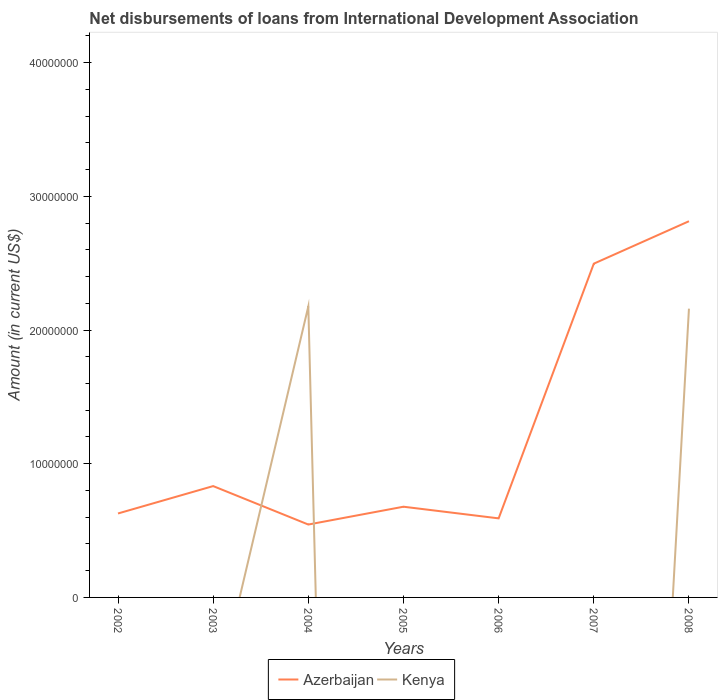How many different coloured lines are there?
Your answer should be very brief. 2. Does the line corresponding to Kenya intersect with the line corresponding to Azerbaijan?
Make the answer very short. Yes. What is the total amount of loans disbursed in Azerbaijan in the graph?
Give a very brief answer. 1.54e+06. What is the difference between the highest and the second highest amount of loans disbursed in Azerbaijan?
Ensure brevity in your answer.  2.27e+07. What is the difference between the highest and the lowest amount of loans disbursed in Azerbaijan?
Offer a terse response. 2. What is the difference between two consecutive major ticks on the Y-axis?
Offer a very short reply. 1.00e+07. Does the graph contain any zero values?
Keep it short and to the point. Yes. Does the graph contain grids?
Provide a short and direct response. No. How many legend labels are there?
Offer a terse response. 2. How are the legend labels stacked?
Ensure brevity in your answer.  Horizontal. What is the title of the graph?
Your response must be concise. Net disbursements of loans from International Development Association. Does "Puerto Rico" appear as one of the legend labels in the graph?
Provide a short and direct response. No. What is the label or title of the X-axis?
Provide a succinct answer. Years. What is the Amount (in current US$) in Azerbaijan in 2002?
Make the answer very short. 6.28e+06. What is the Amount (in current US$) in Azerbaijan in 2003?
Make the answer very short. 8.33e+06. What is the Amount (in current US$) of Azerbaijan in 2004?
Give a very brief answer. 5.45e+06. What is the Amount (in current US$) of Kenya in 2004?
Your answer should be very brief. 2.18e+07. What is the Amount (in current US$) of Azerbaijan in 2005?
Offer a very short reply. 6.78e+06. What is the Amount (in current US$) in Azerbaijan in 2006?
Your response must be concise. 5.91e+06. What is the Amount (in current US$) of Kenya in 2006?
Your answer should be compact. 0. What is the Amount (in current US$) in Azerbaijan in 2007?
Offer a terse response. 2.50e+07. What is the Amount (in current US$) of Kenya in 2007?
Offer a very short reply. 0. What is the Amount (in current US$) in Azerbaijan in 2008?
Make the answer very short. 2.81e+07. What is the Amount (in current US$) in Kenya in 2008?
Make the answer very short. 2.16e+07. Across all years, what is the maximum Amount (in current US$) in Azerbaijan?
Offer a terse response. 2.81e+07. Across all years, what is the maximum Amount (in current US$) of Kenya?
Make the answer very short. 2.18e+07. Across all years, what is the minimum Amount (in current US$) of Azerbaijan?
Provide a succinct answer. 5.45e+06. Across all years, what is the minimum Amount (in current US$) in Kenya?
Give a very brief answer. 0. What is the total Amount (in current US$) in Azerbaijan in the graph?
Offer a very short reply. 8.59e+07. What is the total Amount (in current US$) in Kenya in the graph?
Ensure brevity in your answer.  4.34e+07. What is the difference between the Amount (in current US$) in Azerbaijan in 2002 and that in 2003?
Give a very brief answer. -2.05e+06. What is the difference between the Amount (in current US$) of Azerbaijan in 2002 and that in 2004?
Your answer should be very brief. 8.27e+05. What is the difference between the Amount (in current US$) in Azerbaijan in 2002 and that in 2005?
Ensure brevity in your answer.  -5.05e+05. What is the difference between the Amount (in current US$) of Azerbaijan in 2002 and that in 2006?
Provide a succinct answer. 3.66e+05. What is the difference between the Amount (in current US$) of Azerbaijan in 2002 and that in 2007?
Your answer should be compact. -1.87e+07. What is the difference between the Amount (in current US$) of Azerbaijan in 2002 and that in 2008?
Offer a terse response. -2.19e+07. What is the difference between the Amount (in current US$) in Azerbaijan in 2003 and that in 2004?
Ensure brevity in your answer.  2.88e+06. What is the difference between the Amount (in current US$) of Azerbaijan in 2003 and that in 2005?
Offer a very short reply. 1.54e+06. What is the difference between the Amount (in current US$) in Azerbaijan in 2003 and that in 2006?
Give a very brief answer. 2.41e+06. What is the difference between the Amount (in current US$) in Azerbaijan in 2003 and that in 2007?
Your answer should be very brief. -1.66e+07. What is the difference between the Amount (in current US$) of Azerbaijan in 2003 and that in 2008?
Give a very brief answer. -1.98e+07. What is the difference between the Amount (in current US$) in Azerbaijan in 2004 and that in 2005?
Make the answer very short. -1.33e+06. What is the difference between the Amount (in current US$) in Azerbaijan in 2004 and that in 2006?
Ensure brevity in your answer.  -4.61e+05. What is the difference between the Amount (in current US$) of Azerbaijan in 2004 and that in 2007?
Provide a short and direct response. -1.95e+07. What is the difference between the Amount (in current US$) of Azerbaijan in 2004 and that in 2008?
Offer a terse response. -2.27e+07. What is the difference between the Amount (in current US$) of Kenya in 2004 and that in 2008?
Your response must be concise. 1.68e+05. What is the difference between the Amount (in current US$) of Azerbaijan in 2005 and that in 2006?
Make the answer very short. 8.71e+05. What is the difference between the Amount (in current US$) in Azerbaijan in 2005 and that in 2007?
Offer a very short reply. -1.82e+07. What is the difference between the Amount (in current US$) in Azerbaijan in 2005 and that in 2008?
Provide a short and direct response. -2.14e+07. What is the difference between the Amount (in current US$) of Azerbaijan in 2006 and that in 2007?
Provide a short and direct response. -1.90e+07. What is the difference between the Amount (in current US$) of Azerbaijan in 2006 and that in 2008?
Give a very brief answer. -2.22e+07. What is the difference between the Amount (in current US$) in Azerbaijan in 2007 and that in 2008?
Offer a terse response. -3.17e+06. What is the difference between the Amount (in current US$) in Azerbaijan in 2002 and the Amount (in current US$) in Kenya in 2004?
Keep it short and to the point. -1.55e+07. What is the difference between the Amount (in current US$) in Azerbaijan in 2002 and the Amount (in current US$) in Kenya in 2008?
Provide a succinct answer. -1.53e+07. What is the difference between the Amount (in current US$) of Azerbaijan in 2003 and the Amount (in current US$) of Kenya in 2004?
Offer a terse response. -1.34e+07. What is the difference between the Amount (in current US$) of Azerbaijan in 2003 and the Amount (in current US$) of Kenya in 2008?
Offer a very short reply. -1.33e+07. What is the difference between the Amount (in current US$) in Azerbaijan in 2004 and the Amount (in current US$) in Kenya in 2008?
Offer a very short reply. -1.61e+07. What is the difference between the Amount (in current US$) of Azerbaijan in 2005 and the Amount (in current US$) of Kenya in 2008?
Offer a terse response. -1.48e+07. What is the difference between the Amount (in current US$) in Azerbaijan in 2006 and the Amount (in current US$) in Kenya in 2008?
Your response must be concise. -1.57e+07. What is the difference between the Amount (in current US$) of Azerbaijan in 2007 and the Amount (in current US$) of Kenya in 2008?
Offer a terse response. 3.36e+06. What is the average Amount (in current US$) in Azerbaijan per year?
Provide a succinct answer. 1.23e+07. What is the average Amount (in current US$) in Kenya per year?
Your answer should be compact. 6.19e+06. In the year 2004, what is the difference between the Amount (in current US$) of Azerbaijan and Amount (in current US$) of Kenya?
Offer a terse response. -1.63e+07. In the year 2008, what is the difference between the Amount (in current US$) of Azerbaijan and Amount (in current US$) of Kenya?
Your answer should be very brief. 6.54e+06. What is the ratio of the Amount (in current US$) in Azerbaijan in 2002 to that in 2003?
Your answer should be compact. 0.75. What is the ratio of the Amount (in current US$) in Azerbaijan in 2002 to that in 2004?
Make the answer very short. 1.15. What is the ratio of the Amount (in current US$) in Azerbaijan in 2002 to that in 2005?
Keep it short and to the point. 0.93. What is the ratio of the Amount (in current US$) of Azerbaijan in 2002 to that in 2006?
Provide a succinct answer. 1.06. What is the ratio of the Amount (in current US$) of Azerbaijan in 2002 to that in 2007?
Make the answer very short. 0.25. What is the ratio of the Amount (in current US$) of Azerbaijan in 2002 to that in 2008?
Your response must be concise. 0.22. What is the ratio of the Amount (in current US$) of Azerbaijan in 2003 to that in 2004?
Your answer should be compact. 1.53. What is the ratio of the Amount (in current US$) in Azerbaijan in 2003 to that in 2005?
Ensure brevity in your answer.  1.23. What is the ratio of the Amount (in current US$) in Azerbaijan in 2003 to that in 2006?
Your answer should be compact. 1.41. What is the ratio of the Amount (in current US$) of Azerbaijan in 2003 to that in 2007?
Provide a short and direct response. 0.33. What is the ratio of the Amount (in current US$) in Azerbaijan in 2003 to that in 2008?
Make the answer very short. 0.3. What is the ratio of the Amount (in current US$) in Azerbaijan in 2004 to that in 2005?
Your response must be concise. 0.8. What is the ratio of the Amount (in current US$) of Azerbaijan in 2004 to that in 2006?
Keep it short and to the point. 0.92. What is the ratio of the Amount (in current US$) in Azerbaijan in 2004 to that in 2007?
Your answer should be very brief. 0.22. What is the ratio of the Amount (in current US$) of Azerbaijan in 2004 to that in 2008?
Offer a terse response. 0.19. What is the ratio of the Amount (in current US$) of Kenya in 2004 to that in 2008?
Your answer should be compact. 1.01. What is the ratio of the Amount (in current US$) of Azerbaijan in 2005 to that in 2006?
Offer a terse response. 1.15. What is the ratio of the Amount (in current US$) of Azerbaijan in 2005 to that in 2007?
Your response must be concise. 0.27. What is the ratio of the Amount (in current US$) in Azerbaijan in 2005 to that in 2008?
Offer a terse response. 0.24. What is the ratio of the Amount (in current US$) of Azerbaijan in 2006 to that in 2007?
Make the answer very short. 0.24. What is the ratio of the Amount (in current US$) in Azerbaijan in 2006 to that in 2008?
Your answer should be compact. 0.21. What is the ratio of the Amount (in current US$) in Azerbaijan in 2007 to that in 2008?
Provide a succinct answer. 0.89. What is the difference between the highest and the second highest Amount (in current US$) in Azerbaijan?
Provide a succinct answer. 3.17e+06. What is the difference between the highest and the lowest Amount (in current US$) in Azerbaijan?
Provide a succinct answer. 2.27e+07. What is the difference between the highest and the lowest Amount (in current US$) of Kenya?
Give a very brief answer. 2.18e+07. 